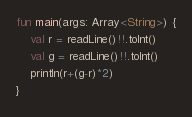Convert code to text. <code><loc_0><loc_0><loc_500><loc_500><_Kotlin_>fun main(args: Array<String>) {
	val r = readLine()!!.toInt()
	val g = readLine()!!.toInt()
	println(r+(g-r)*2)
}

</code> 